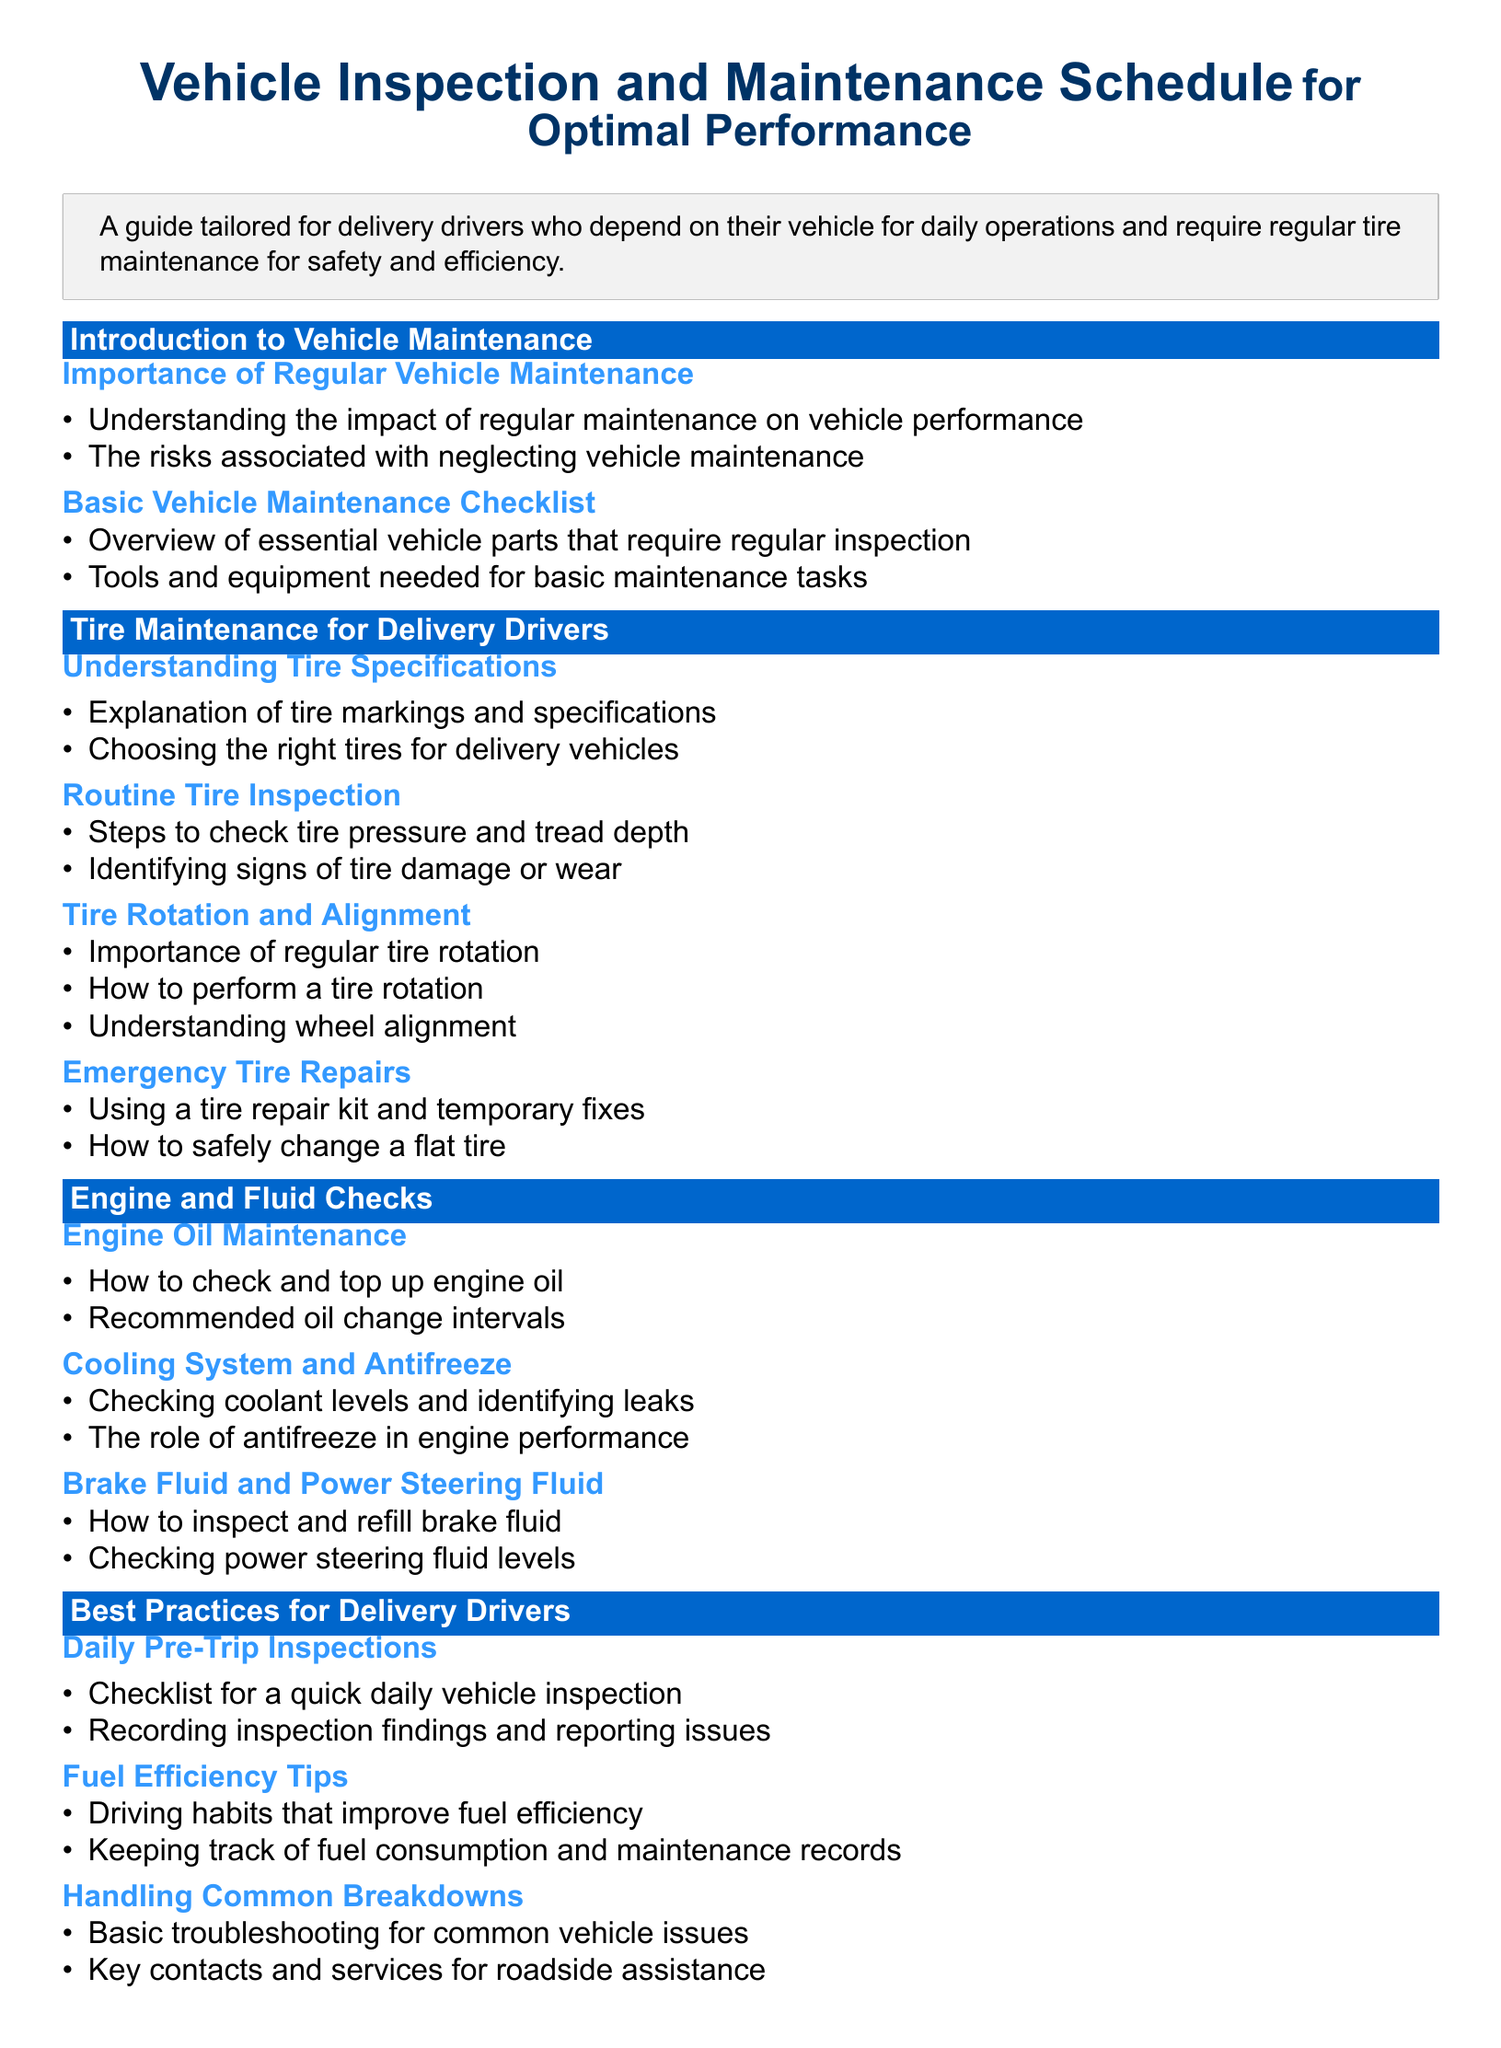What is the importance of regular vehicle maintenance? The document states that regular maintenance impacts vehicle performance and neglecting it poses risks.
Answer: Vehicle performance and risks What should you check in a daily pre-trip inspection? A checklist for a quick daily vehicle inspection is provided, outlining key areas to review.
Answer: Checklist for vehicle inspection How often should engine oil be changed? The syllabus mentions "recommended oil change intervals," implying a specific frequency for oil changes.
Answer: Recommended intervals What are the steps to check tire pressure? The document outlines the steps to check tire pressure, among other tire maintenance practices.
Answer: Steps to check tire pressure What is the role of antifreeze in engine performance? The syllabus explains the importance of antifreeze within the cooling system.
Answer: Engine performance What is mentioned about tire rotation? The syllabus describes the importance of regular tire rotation and how to perform it.
Answer: Importance of tire rotation How to inspect power steering fluid levels? The document specifies the procedure for checking power steering fluid levels.
Answer: Inspecting power steering fluid What tool is mentioned for emergency tire repairs? The syllabus references a tire repair kit as a necessary tool for emergency situations.
Answer: Tire repair kit How are tire specifications described? There is an explanation of tire markings and specifications relevant for delivery vehicles.
Answer: Tire markings and specifications 